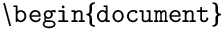Convert formula to latex. <formula><loc_0><loc_0><loc_500><loc_500>\ b e g i n \{ d o c u m e n t \}</formula> 